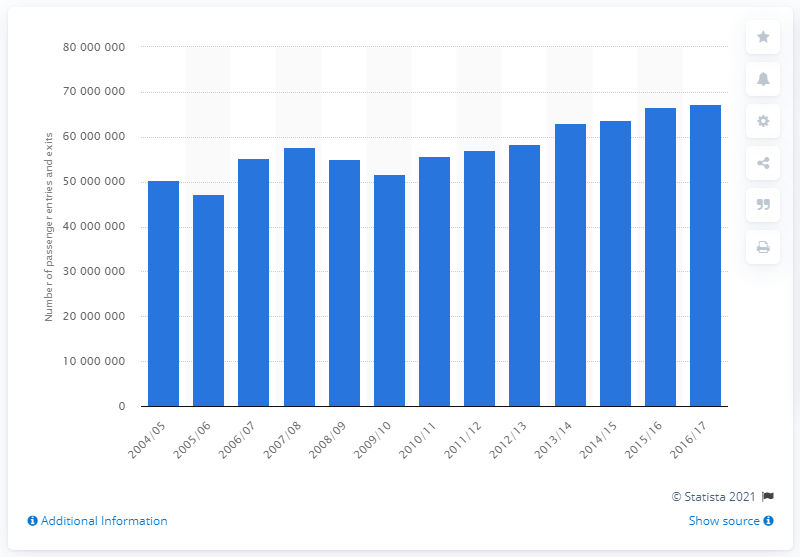Specify some key components in this picture. In the year 2016/17, a total of 673,392,185 passengers utilized Liverpool Street Station. 